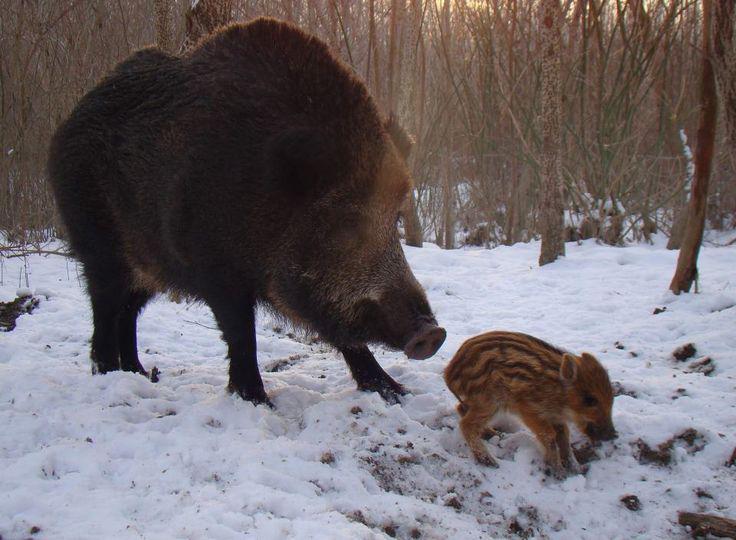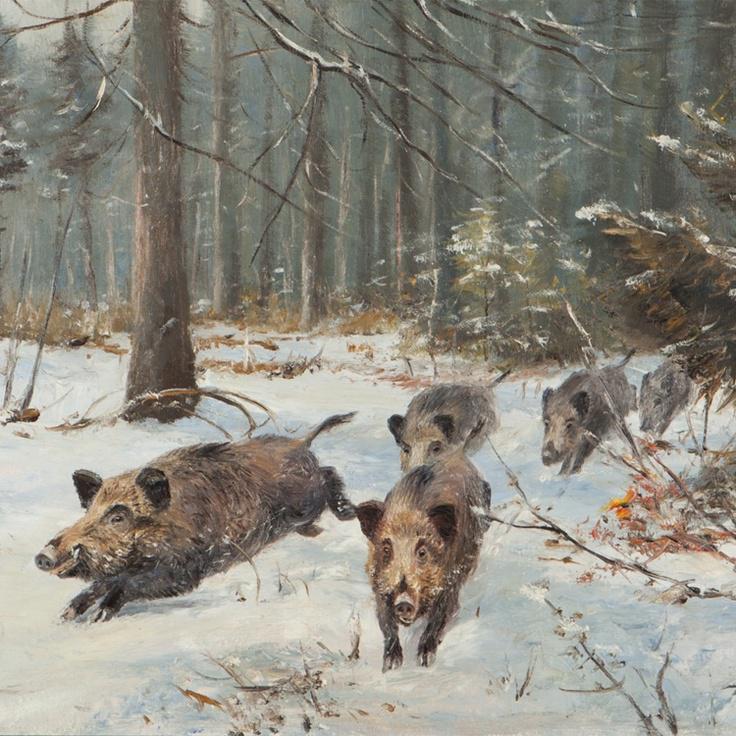The first image is the image on the left, the second image is the image on the right. Examine the images to the left and right. Is the description "An image contains only one adult boar, which is dark and turned with its body toward the right." accurate? Answer yes or no. Yes. The first image is the image on the left, the second image is the image on the right. Evaluate the accuracy of this statement regarding the images: "there is exactly one adult boar in one of the images". Is it true? Answer yes or no. Yes. 